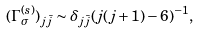<formula> <loc_0><loc_0><loc_500><loc_500>( \Gamma _ { \sigma } ^ { ( s ) } ) _ { j \bar { j } } \sim \delta _ { j \bar { j } } ( j ( j + 1 ) - 6 ) ^ { - 1 } ,</formula> 